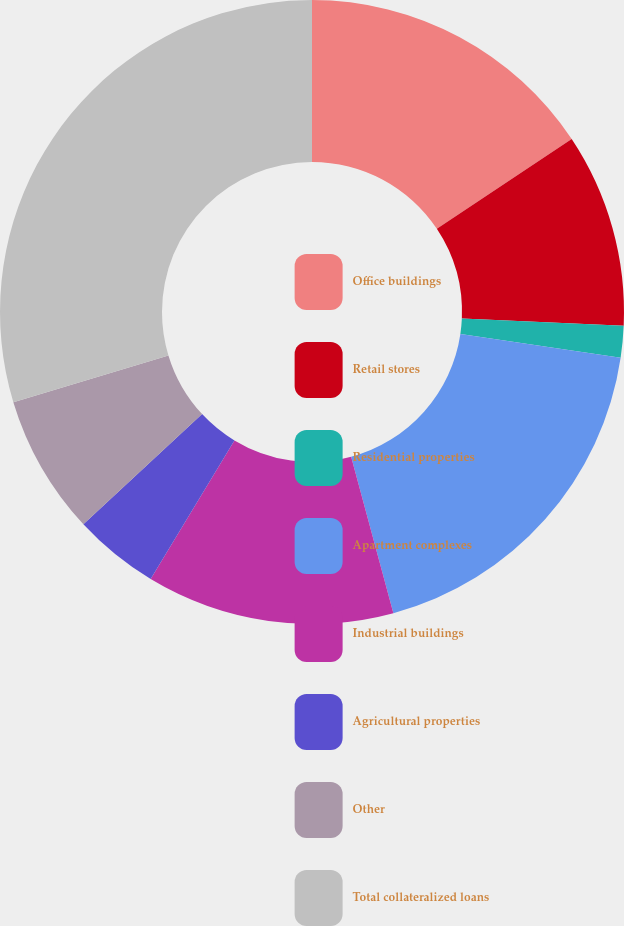<chart> <loc_0><loc_0><loc_500><loc_500><pie_chart><fcel>Office buildings<fcel>Retail stores<fcel>Residential properties<fcel>Apartment complexes<fcel>Industrial buildings<fcel>Agricultural properties<fcel>Other<fcel>Total collateralized loans<nl><fcel>15.65%<fcel>10.05%<fcel>1.64%<fcel>18.46%<fcel>12.85%<fcel>4.44%<fcel>7.24%<fcel>29.67%<nl></chart> 